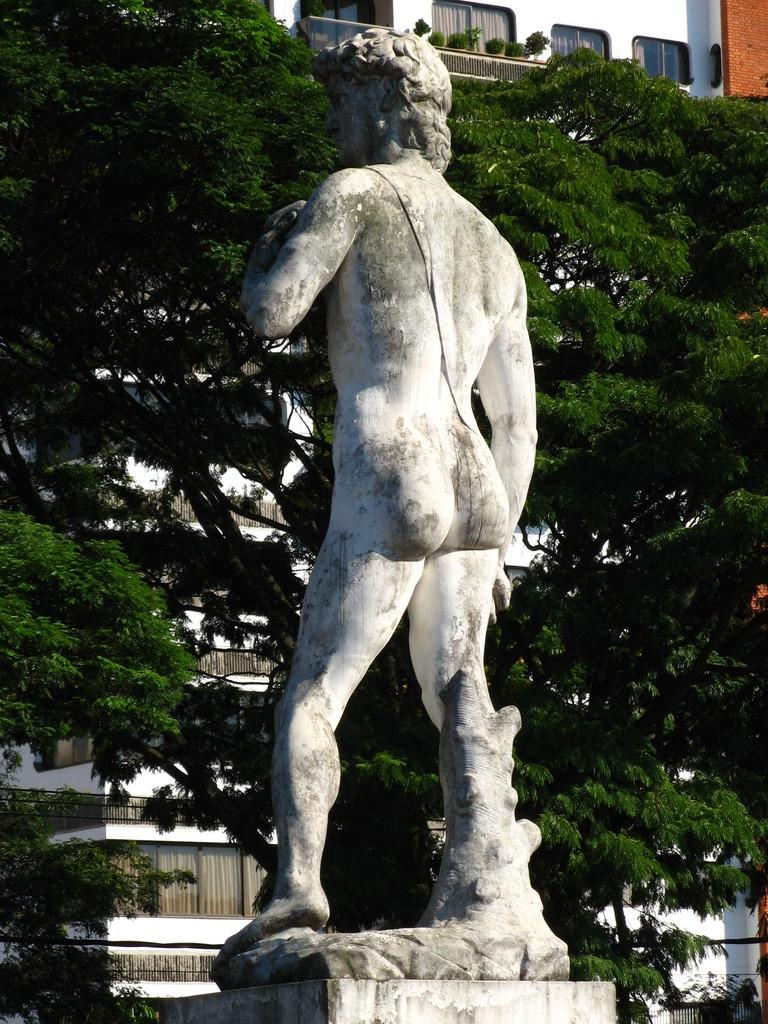What is the main subject of the image? There is a statue of a person in the image. What can be seen in the background of the image? There are trees and buildings in the background of the image. How many clocks are hanging from the statue in the image? There are no clocks present in the image; it features a statue of a person with no visible clocks. What type of carriage is parked next to the statue in the image? There is no carriage present in the image; it only features a statue of a person and the background with trees and buildings. 